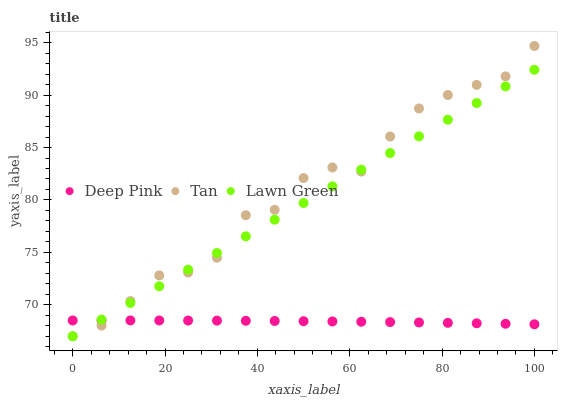Does Deep Pink have the minimum area under the curve?
Answer yes or no. Yes. Does Tan have the maximum area under the curve?
Answer yes or no. Yes. Does Tan have the minimum area under the curve?
Answer yes or no. No. Does Deep Pink have the maximum area under the curve?
Answer yes or no. No. Is Lawn Green the smoothest?
Answer yes or no. Yes. Is Tan the roughest?
Answer yes or no. Yes. Is Deep Pink the smoothest?
Answer yes or no. No. Is Deep Pink the roughest?
Answer yes or no. No. Does Lawn Green have the lowest value?
Answer yes or no. Yes. Does Deep Pink have the lowest value?
Answer yes or no. No. Does Tan have the highest value?
Answer yes or no. Yes. Does Deep Pink have the highest value?
Answer yes or no. No. Does Lawn Green intersect Deep Pink?
Answer yes or no. Yes. Is Lawn Green less than Deep Pink?
Answer yes or no. No. Is Lawn Green greater than Deep Pink?
Answer yes or no. No. 